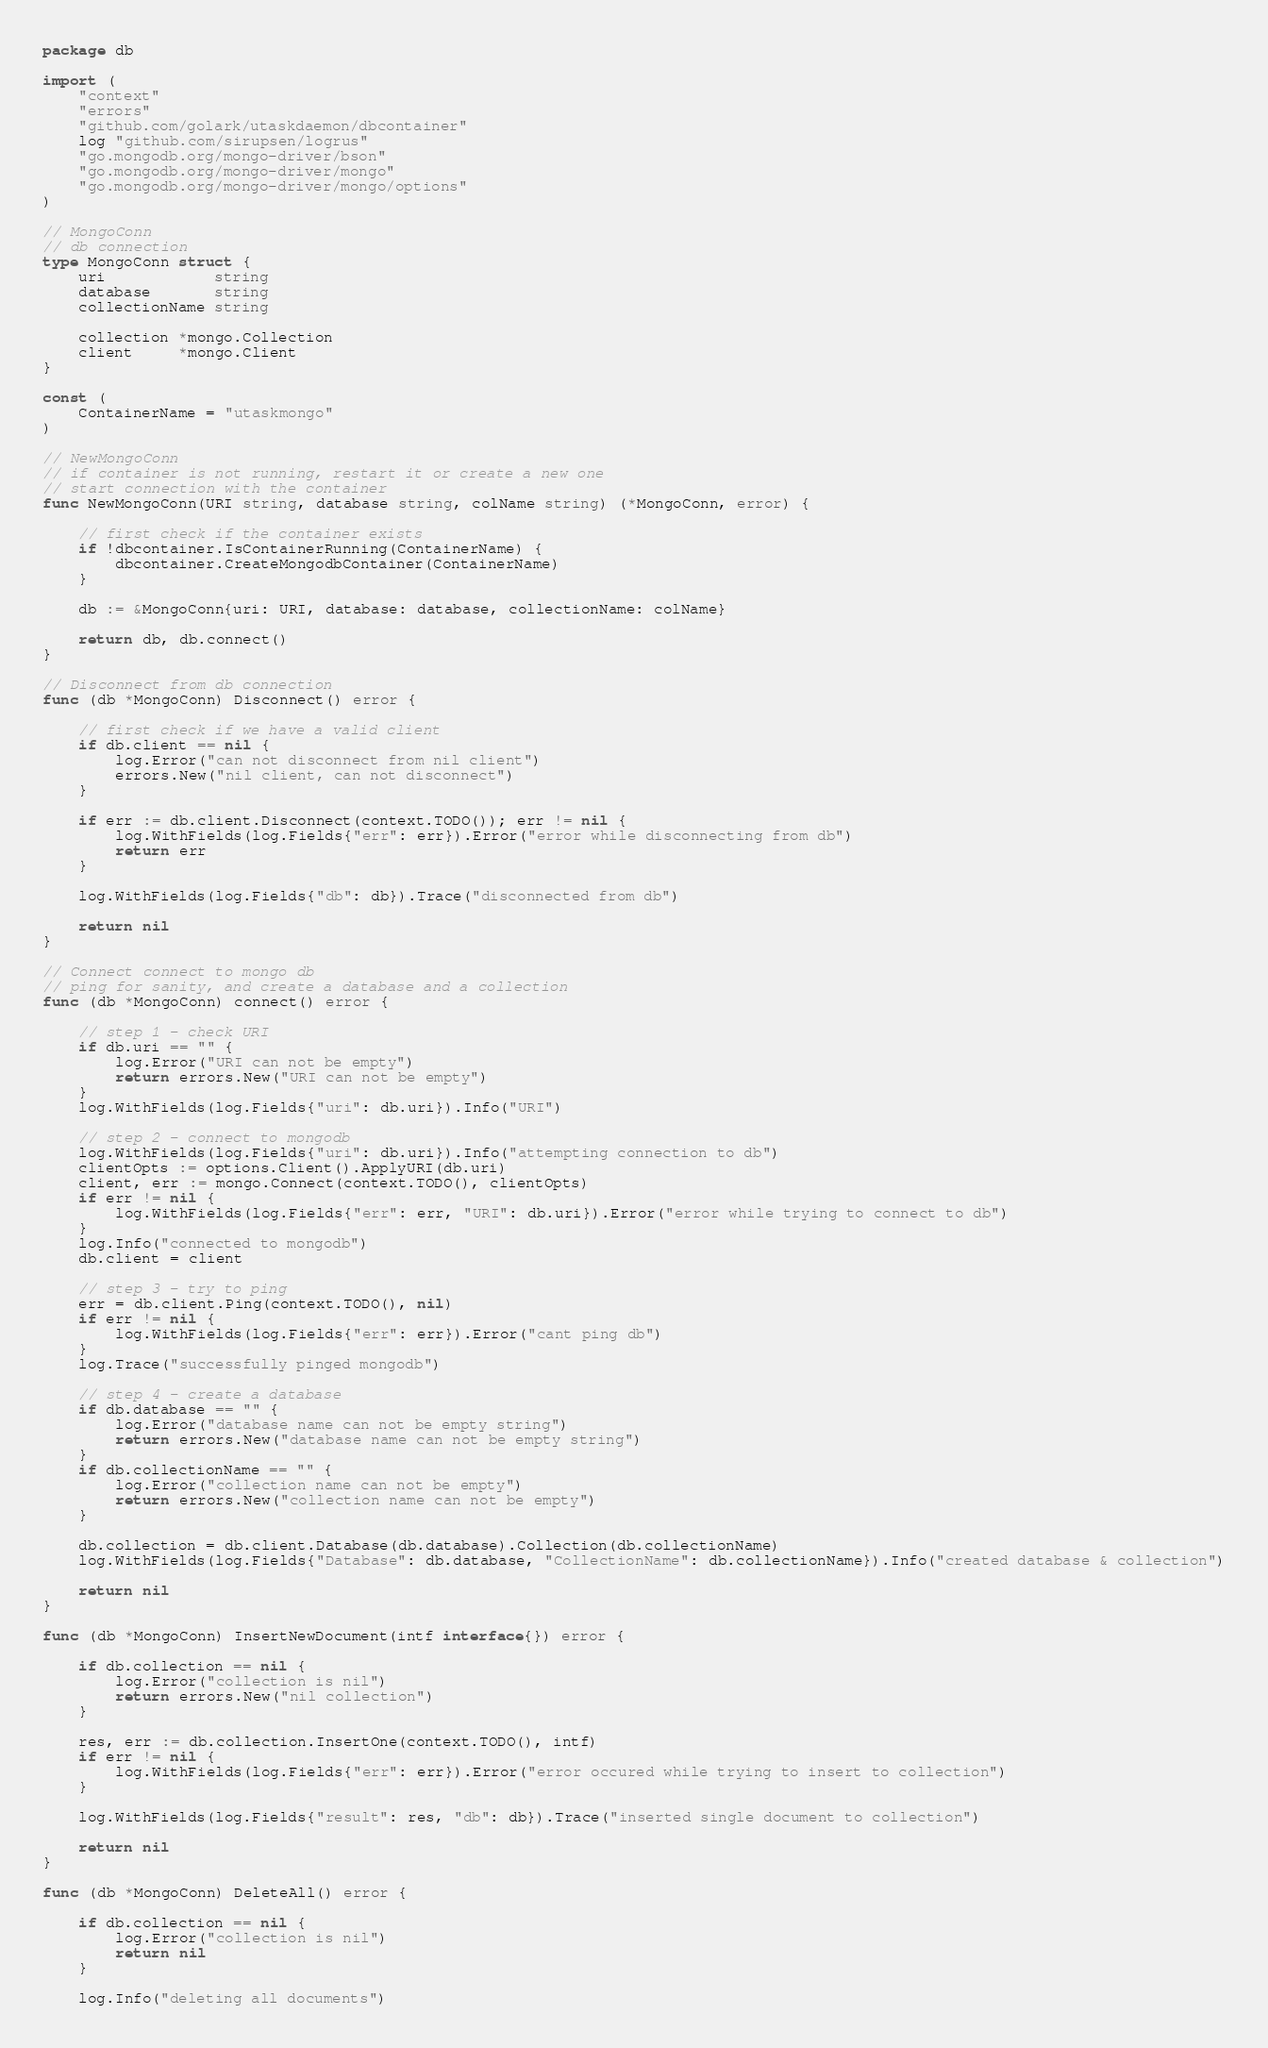<code> <loc_0><loc_0><loc_500><loc_500><_Go_>package db

import (
	"context"
	"errors"
	"github.com/golark/utaskdaemon/dbcontainer"
	log "github.com/sirupsen/logrus"
	"go.mongodb.org/mongo-driver/bson"
	"go.mongodb.org/mongo-driver/mongo"
	"go.mongodb.org/mongo-driver/mongo/options"
)

// MongoConn
// db connection
type MongoConn struct {
	uri            string
	database       string
	collectionName string

	collection *mongo.Collection
	client     *mongo.Client
}

const (
	ContainerName = "utaskmongo"
)

// NewMongoConn
// if container is not running, restart it or create a new one
// start connection with the container
func NewMongoConn(URI string, database string, colName string) (*MongoConn, error) {

	// first check if the container exists
	if !dbcontainer.IsContainerRunning(ContainerName) {
		dbcontainer.CreateMongodbContainer(ContainerName)
	}

	db := &MongoConn{uri: URI, database: database, collectionName: colName}

	return db, db.connect()
}

// Disconnect from db connection
func (db *MongoConn) Disconnect() error {

	// first check if we have a valid client
	if db.client == nil {
		log.Error("can not disconnect from nil client")
		errors.New("nil client, can not disconnect")
	}

	if err := db.client.Disconnect(context.TODO()); err != nil {
		log.WithFields(log.Fields{"err": err}).Error("error while disconnecting from db")
		return err
	}

	log.WithFields(log.Fields{"db": db}).Trace("disconnected from db")

	return nil
}

// Connect connect to mongo db
// ping for sanity, and create a database and a collection
func (db *MongoConn) connect() error {

	// step 1 - check URI
	if db.uri == "" {
		log.Error("URI can not be empty")
		return errors.New("URI can not be empty")
	}
	log.WithFields(log.Fields{"uri": db.uri}).Info("URI")

	// step 2 - connect to mongodb
	log.WithFields(log.Fields{"uri": db.uri}).Info("attempting connection to db")
	clientOpts := options.Client().ApplyURI(db.uri)
	client, err := mongo.Connect(context.TODO(), clientOpts)
	if err != nil {
		log.WithFields(log.Fields{"err": err, "URI": db.uri}).Error("error while trying to connect to db")
	}
	log.Info("connected to mongodb")
	db.client = client

	// step 3 - try to ping
	err = db.client.Ping(context.TODO(), nil)
	if err != nil {
		log.WithFields(log.Fields{"err": err}).Error("cant ping db")
	}
	log.Trace("successfully pinged mongodb")

	// step 4 - create a database
	if db.database == "" {
		log.Error("database name can not be empty string")
		return errors.New("database name can not be empty string")
	}
	if db.collectionName == "" {
		log.Error("collection name can not be empty")
		return errors.New("collection name can not be empty")
	}

	db.collection = db.client.Database(db.database).Collection(db.collectionName)
	log.WithFields(log.Fields{"Database": db.database, "CollectionName": db.collectionName}).Info("created database & collection")

	return nil
}

func (db *MongoConn) InsertNewDocument(intf interface{}) error {

	if db.collection == nil {
		log.Error("collection is nil")
		return errors.New("nil collection")
	}

	res, err := db.collection.InsertOne(context.TODO(), intf)
	if err != nil {
		log.WithFields(log.Fields{"err": err}).Error("error occured while trying to insert to collection")
	}

	log.WithFields(log.Fields{"result": res, "db": db}).Trace("inserted single document to collection")

	return nil
}

func (db *MongoConn) DeleteAll() error {

	if db.collection == nil {
		log.Error("collection is nil")
		return nil
	}

	log.Info("deleting all documents")</code> 